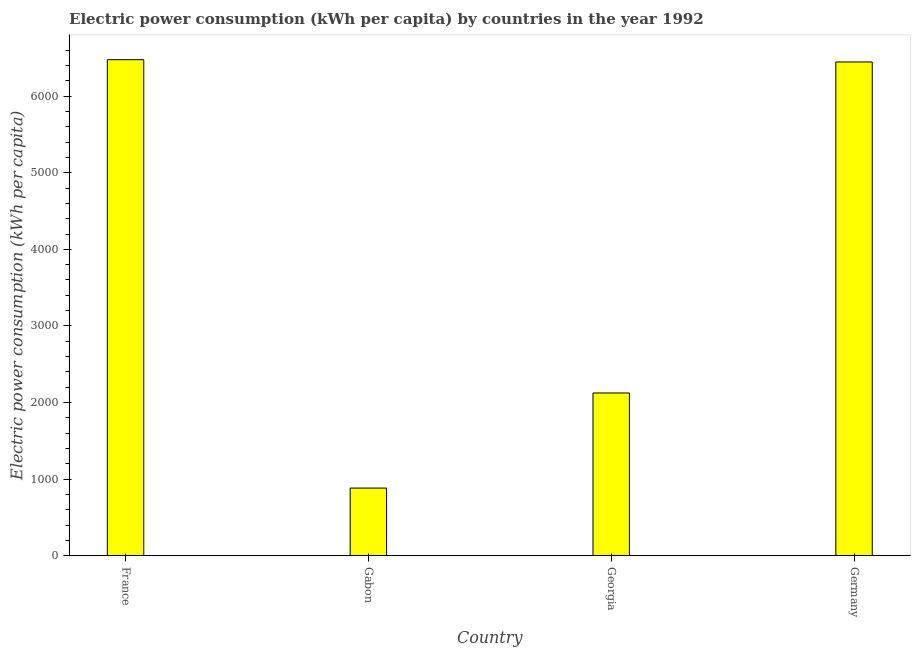Does the graph contain any zero values?
Ensure brevity in your answer.  No. What is the title of the graph?
Provide a short and direct response. Electric power consumption (kWh per capita) by countries in the year 1992. What is the label or title of the X-axis?
Provide a succinct answer. Country. What is the label or title of the Y-axis?
Offer a very short reply. Electric power consumption (kWh per capita). What is the electric power consumption in Georgia?
Ensure brevity in your answer.  2125.17. Across all countries, what is the maximum electric power consumption?
Give a very brief answer. 6475.79. Across all countries, what is the minimum electric power consumption?
Provide a succinct answer. 883.94. In which country was the electric power consumption minimum?
Make the answer very short. Gabon. What is the sum of the electric power consumption?
Offer a very short reply. 1.59e+04. What is the difference between the electric power consumption in France and Germany?
Your response must be concise. 29.91. What is the average electric power consumption per country?
Ensure brevity in your answer.  3982.69. What is the median electric power consumption?
Your answer should be very brief. 4285.52. What is the ratio of the electric power consumption in Gabon to that in Germany?
Offer a very short reply. 0.14. Is the electric power consumption in France less than that in Germany?
Provide a succinct answer. No. Is the difference between the electric power consumption in France and Georgia greater than the difference between any two countries?
Your answer should be compact. No. What is the difference between the highest and the second highest electric power consumption?
Your answer should be compact. 29.91. What is the difference between the highest and the lowest electric power consumption?
Provide a succinct answer. 5591.85. How many bars are there?
Offer a very short reply. 4. Are all the bars in the graph horizontal?
Your response must be concise. No. How many countries are there in the graph?
Ensure brevity in your answer.  4. What is the Electric power consumption (kWh per capita) of France?
Offer a terse response. 6475.79. What is the Electric power consumption (kWh per capita) in Gabon?
Keep it short and to the point. 883.94. What is the Electric power consumption (kWh per capita) in Georgia?
Offer a terse response. 2125.17. What is the Electric power consumption (kWh per capita) of Germany?
Your response must be concise. 6445.87. What is the difference between the Electric power consumption (kWh per capita) in France and Gabon?
Provide a short and direct response. 5591.85. What is the difference between the Electric power consumption (kWh per capita) in France and Georgia?
Your response must be concise. 4350.62. What is the difference between the Electric power consumption (kWh per capita) in France and Germany?
Your answer should be very brief. 29.91. What is the difference between the Electric power consumption (kWh per capita) in Gabon and Georgia?
Provide a succinct answer. -1241.23. What is the difference between the Electric power consumption (kWh per capita) in Gabon and Germany?
Provide a short and direct response. -5561.94. What is the difference between the Electric power consumption (kWh per capita) in Georgia and Germany?
Your response must be concise. -4320.71. What is the ratio of the Electric power consumption (kWh per capita) in France to that in Gabon?
Give a very brief answer. 7.33. What is the ratio of the Electric power consumption (kWh per capita) in France to that in Georgia?
Your answer should be very brief. 3.05. What is the ratio of the Electric power consumption (kWh per capita) in France to that in Germany?
Provide a short and direct response. 1. What is the ratio of the Electric power consumption (kWh per capita) in Gabon to that in Georgia?
Offer a terse response. 0.42. What is the ratio of the Electric power consumption (kWh per capita) in Gabon to that in Germany?
Give a very brief answer. 0.14. What is the ratio of the Electric power consumption (kWh per capita) in Georgia to that in Germany?
Offer a terse response. 0.33. 